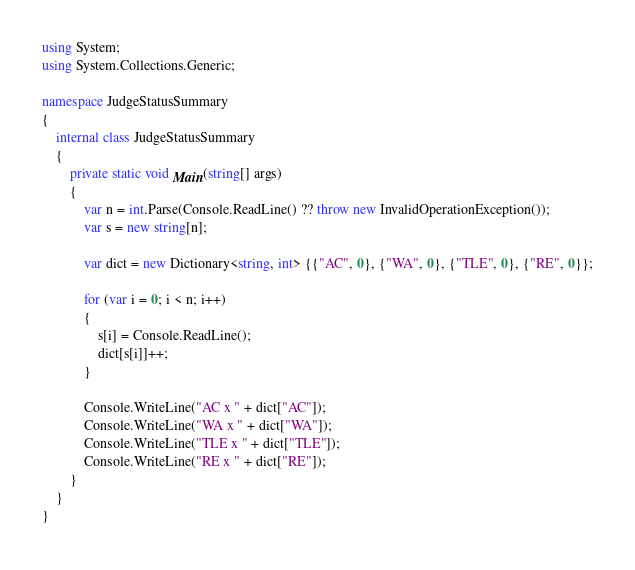<code> <loc_0><loc_0><loc_500><loc_500><_C#_>using System;
using System.Collections.Generic;

namespace JudgeStatusSummary
{
    internal class JudgeStatusSummary
    {
        private static void Main(string[] args)
        {
            var n = int.Parse(Console.ReadLine() ?? throw new InvalidOperationException());
            var s = new string[n];

            var dict = new Dictionary<string, int> {{"AC", 0}, {"WA", 0}, {"TLE", 0}, {"RE", 0}};

            for (var i = 0; i < n; i++)
            {
                s[i] = Console.ReadLine();
                dict[s[i]]++;
            }

            Console.WriteLine("AC x " + dict["AC"]);
            Console.WriteLine("WA x " + dict["WA"]);
            Console.WriteLine("TLE x " + dict["TLE"]);
            Console.WriteLine("RE x " + dict["RE"]);
        }
    }
}</code> 